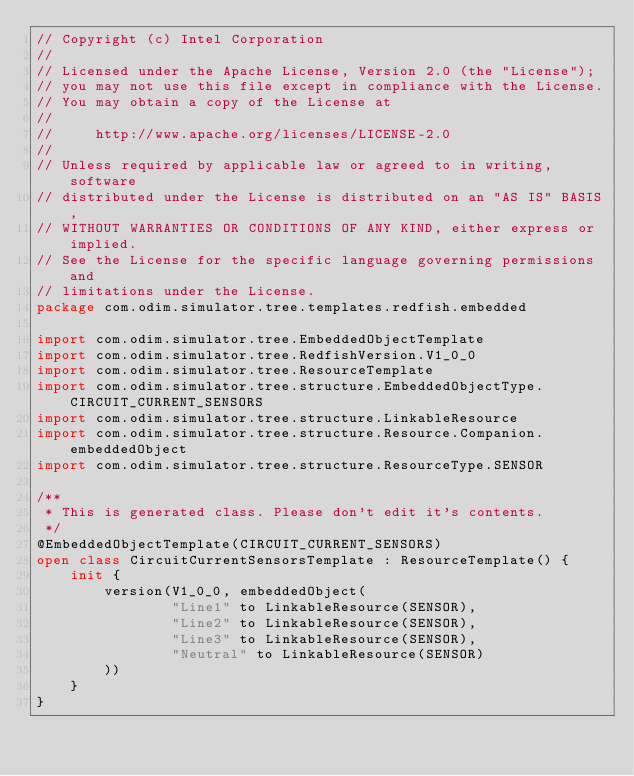<code> <loc_0><loc_0><loc_500><loc_500><_Kotlin_>// Copyright (c) Intel Corporation
//
// Licensed under the Apache License, Version 2.0 (the "License");
// you may not use this file except in compliance with the License.
// You may obtain a copy of the License at
//
//     http://www.apache.org/licenses/LICENSE-2.0
//
// Unless required by applicable law or agreed to in writing, software
// distributed under the License is distributed on an "AS IS" BASIS,
// WITHOUT WARRANTIES OR CONDITIONS OF ANY KIND, either express or implied.
// See the License for the specific language governing permissions and
// limitations under the License.
package com.odim.simulator.tree.templates.redfish.embedded

import com.odim.simulator.tree.EmbeddedObjectTemplate
import com.odim.simulator.tree.RedfishVersion.V1_0_0
import com.odim.simulator.tree.ResourceTemplate
import com.odim.simulator.tree.structure.EmbeddedObjectType.CIRCUIT_CURRENT_SENSORS
import com.odim.simulator.tree.structure.LinkableResource
import com.odim.simulator.tree.structure.Resource.Companion.embeddedObject
import com.odim.simulator.tree.structure.ResourceType.SENSOR

/**
 * This is generated class. Please don't edit it's contents.
 */
@EmbeddedObjectTemplate(CIRCUIT_CURRENT_SENSORS)
open class CircuitCurrentSensorsTemplate : ResourceTemplate() {
    init {
        version(V1_0_0, embeddedObject(
                "Line1" to LinkableResource(SENSOR),
                "Line2" to LinkableResource(SENSOR),
                "Line3" to LinkableResource(SENSOR),
                "Neutral" to LinkableResource(SENSOR)
        ))
    }
}
</code> 